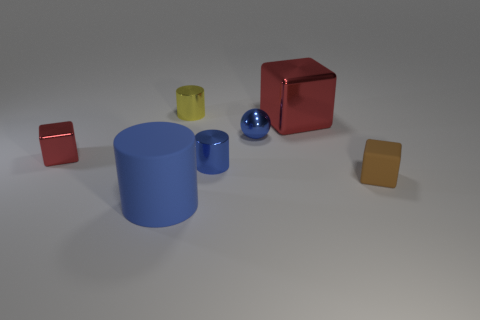Subtract all metal cylinders. How many cylinders are left? 1 Subtract all blue cylinders. How many cylinders are left? 1 Add 1 small metallic blocks. How many objects exist? 8 Subtract 2 cylinders. How many cylinders are left? 1 Subtract all blue blocks. Subtract all big red shiny cubes. How many objects are left? 6 Add 3 small yellow cylinders. How many small yellow cylinders are left? 4 Add 6 red objects. How many red objects exist? 8 Subtract 0 brown cylinders. How many objects are left? 7 Subtract all balls. How many objects are left? 6 Subtract all red spheres. Subtract all blue cylinders. How many spheres are left? 1 